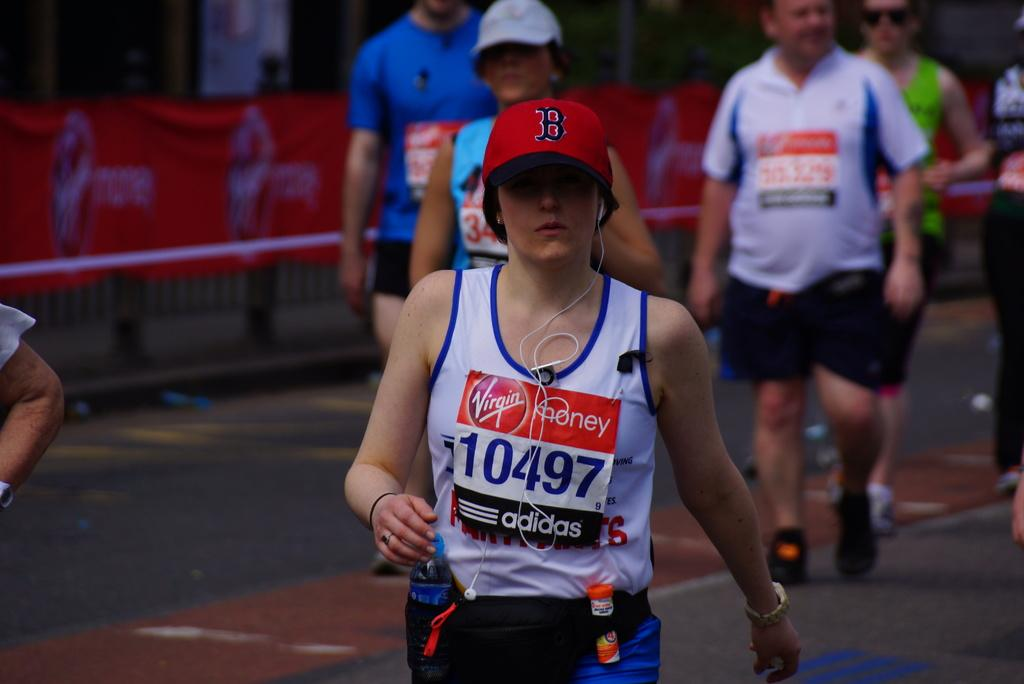<image>
Share a concise interpretation of the image provided. people in a running race wear bibs from Adidas 